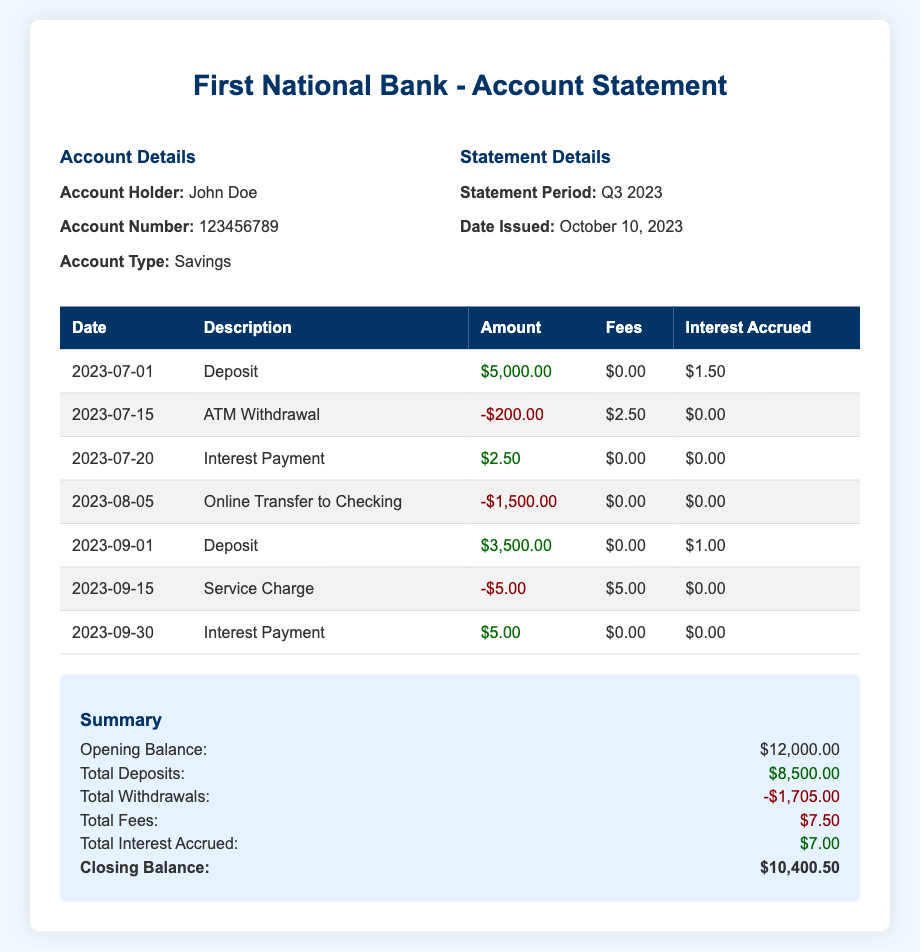What is the account holder's name? The account holder's name is stated in the account details section.
Answer: John Doe What is the account number? The account number is provided in the account details section of the document.
Answer: 123456789 What is the statement period? The statement period is indicated in the statement details section.
Answer: Q3 2023 What is the total amount of fees incurred? The total fees are calculated from the fees listed in the transactions and summarized at the end.
Answer: $7.50 What is the closing balance of the account? The closing balance is given in the summary section.
Answer: $10,400.50 How many deposits were made during the statement period? The number of deposits is determined by the transactions listed in the table.
Answer: 3 What was the highest amount deposited? The highest deposit amount can be found by reviewing the deposits in the transaction table.
Answer: $5,000.00 What kind of charges were applied on September 15, 2023? The type of charge can be found by looking at the description of the transaction on that date.
Answer: Service Charge What was the interest accrued during the statement period? The total interest accrued sums up all interest payments made in the transactions.
Answer: $7.00 What was the date of the issued statement? The date issued is part of the statement details section in the document.
Answer: October 10, 2023 